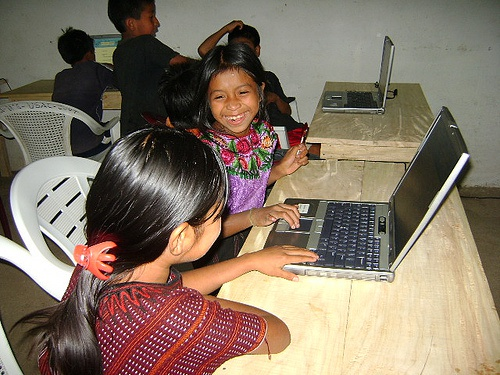Describe the objects in this image and their specific colors. I can see people in black, maroon, tan, and gray tones, laptop in black, gray, and lightgray tones, people in black, salmon, tan, and brown tones, chair in black, lightgray, and darkgray tones, and people in black, maroon, and gray tones in this image. 